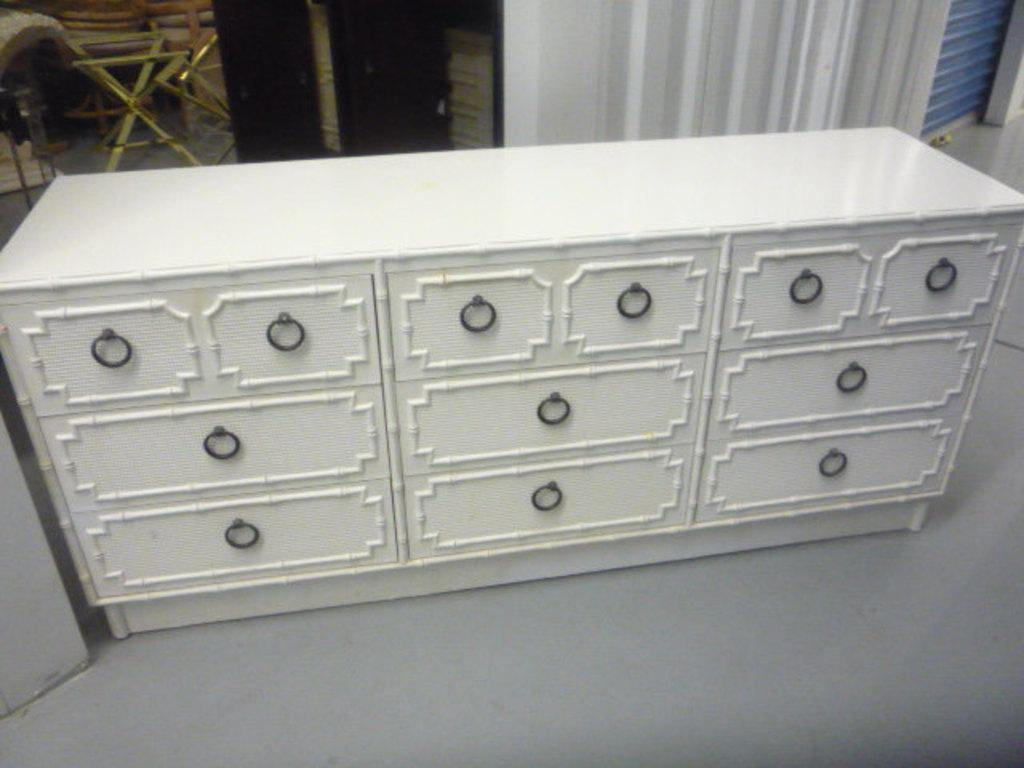What type of furniture is present in the image? There are cupboards in the image. What is the background of the image made of? There is a wall in the image. What can be seen on the right side of the image? There is a rolling shutter on the right side of the image. Is there a cave visible in the image? No, there is no cave present in the image. What type of material is the glass made of in the image? There is no glass present in the image. 